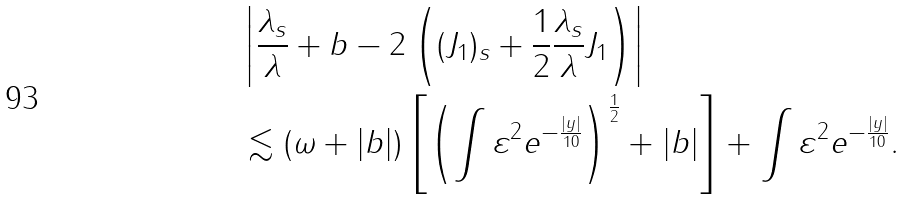Convert formula to latex. <formula><loc_0><loc_0><loc_500><loc_500>& \left | \frac { \lambda _ { s } } { \lambda } + b - 2 \left ( ( J _ { 1 } ) _ { s } + \frac { 1 } { 2 } \frac { \lambda _ { s } } { \lambda } J _ { 1 } \right ) \right | \\ & \lesssim ( \omega + | b | ) \left [ \left ( \int \varepsilon ^ { 2 } e ^ { - \frac { | y | } { 1 0 } } \right ) ^ { \frac { 1 } { 2 } } + | b | \right ] + \int \varepsilon ^ { 2 } e ^ { - \frac { | y | } { 1 0 } } .</formula> 